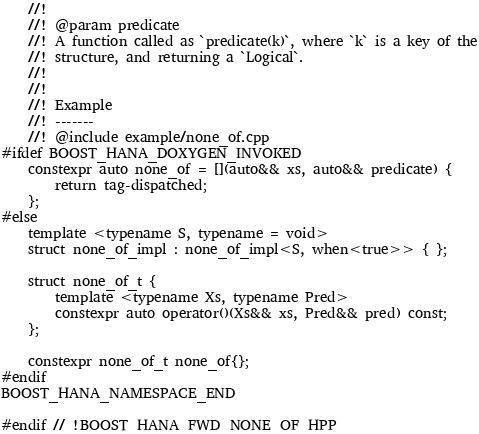<code> <loc_0><loc_0><loc_500><loc_500><_C++_>    //!
    //! @param predicate
    //! A function called as `predicate(k)`, where `k` is a key of the
    //! structure, and returning a `Logical`.
    //!
    //!
    //! Example
    //! -------
    //! @include example/none_of.cpp
#ifdef BOOST_HANA_DOXYGEN_INVOKED
    constexpr auto none_of = [](auto&& xs, auto&& predicate) {
        return tag-dispatched;
    };
#else
    template <typename S, typename = void>
    struct none_of_impl : none_of_impl<S, when<true>> { };

    struct none_of_t {
        template <typename Xs, typename Pred>
        constexpr auto operator()(Xs&& xs, Pred&& pred) const;
    };

    constexpr none_of_t none_of{};
#endif
BOOST_HANA_NAMESPACE_END

#endif // !BOOST_HANA_FWD_NONE_OF_HPP
</code> 